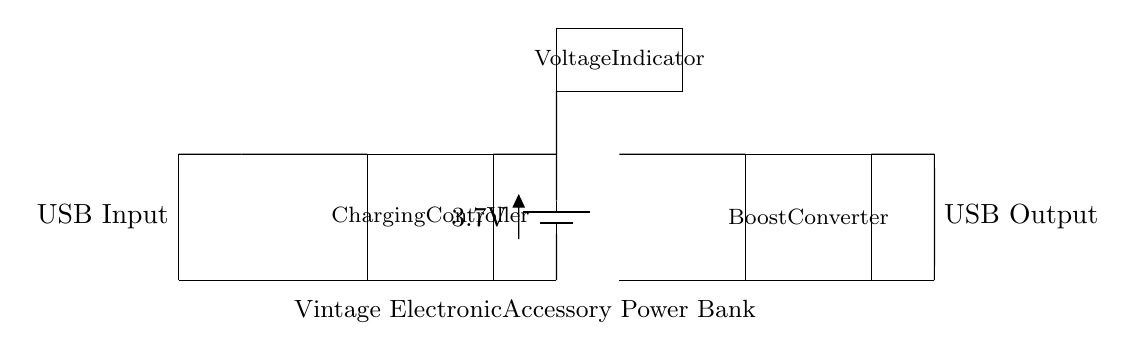What is the source voltage for the battery? The battery is marked with a voltage of 3.7V, which indicates the voltage it supplies for charging.
Answer: 3.7V What component regulates the charging process? The circuit contains a "Charging Controller" between the USB input and the battery, which is responsible for managing the charging of the battery from the USB power source.
Answer: Charging Controller What voltage does the Boost Converter output? The Boost Converter is used to increase the voltage from the battery to the USB output level. While the output voltage isn’t explicitly stated, it typically boosts to 5V to match standard USB output requirements.
Answer: 5V What purpose does the Voltage Indicator serve? The Voltage Indicator in the circuit provides a visual representation of the battery voltage, helping users monitor the battery status and detect any issues with charging or discharging.
Answer: Battery status monitoring How does power flow from the USB Input to the USB Output? Power starts from the USB Input, flows through the Charging Controller which charges the battery, then goes through the Boost Converter that steps up the voltage for the USB Output. This sequential flow ensures proper voltage and functionality.
Answer: USB Input → Charging Controller → Battery → Boost Converter → USB Output 